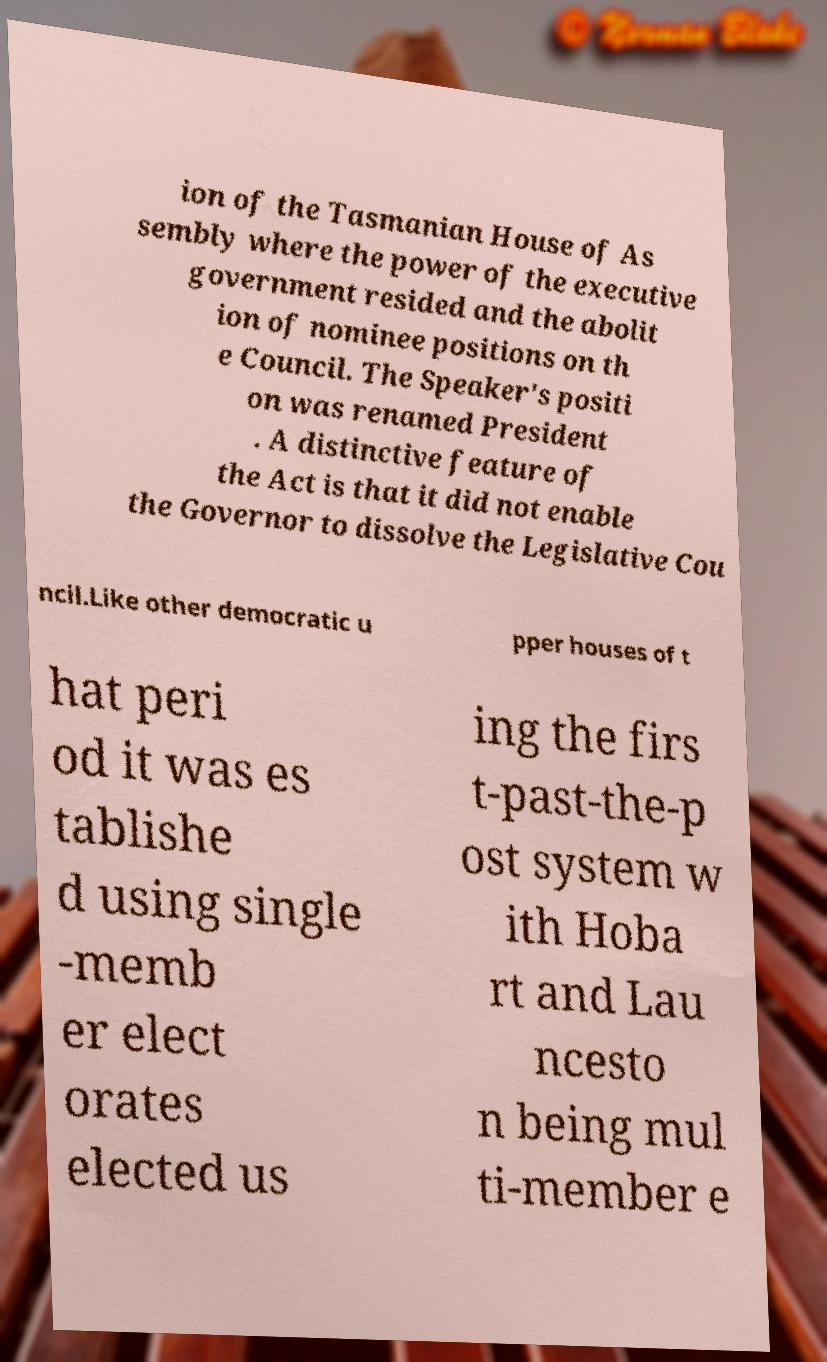What messages or text are displayed in this image? I need them in a readable, typed format. ion of the Tasmanian House of As sembly where the power of the executive government resided and the abolit ion of nominee positions on th e Council. The Speaker's positi on was renamed President . A distinctive feature of the Act is that it did not enable the Governor to dissolve the Legislative Cou ncil.Like other democratic u pper houses of t hat peri od it was es tablishe d using single -memb er elect orates elected us ing the firs t-past-the-p ost system w ith Hoba rt and Lau ncesto n being mul ti-member e 